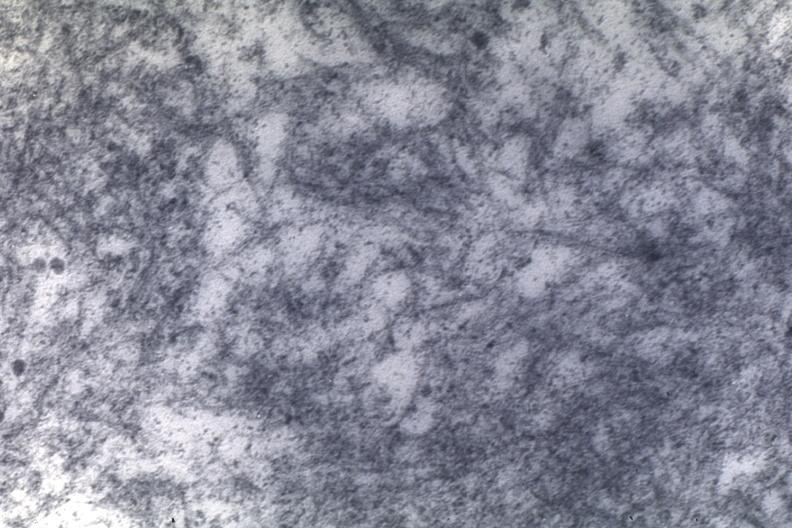s retroperitoneum present?
Answer the question using a single word or phrase. No 